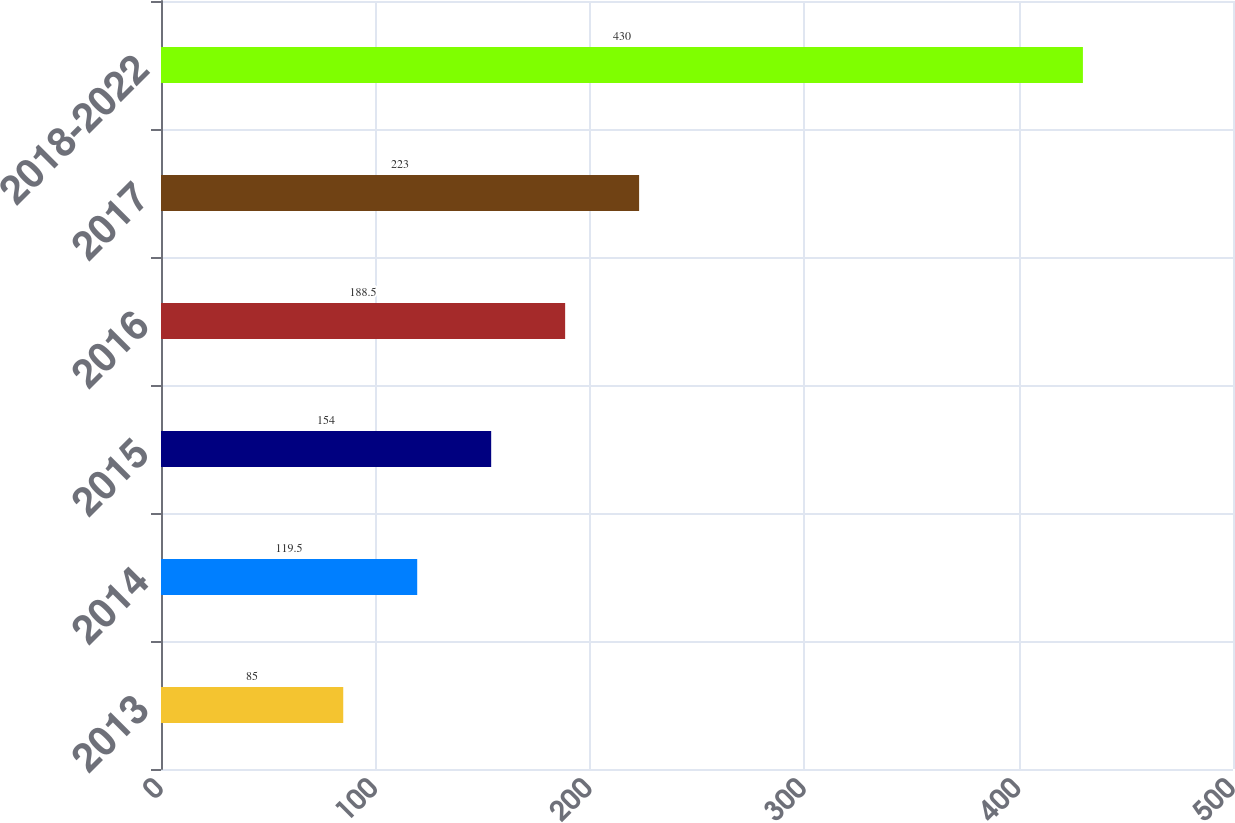Convert chart to OTSL. <chart><loc_0><loc_0><loc_500><loc_500><bar_chart><fcel>2013<fcel>2014<fcel>2015<fcel>2016<fcel>2017<fcel>2018-2022<nl><fcel>85<fcel>119.5<fcel>154<fcel>188.5<fcel>223<fcel>430<nl></chart> 